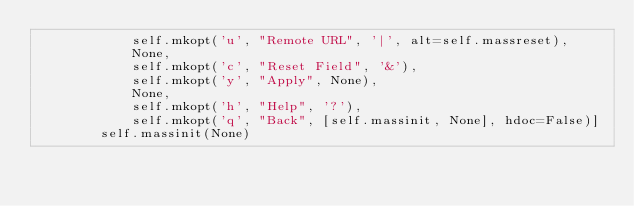<code> <loc_0><loc_0><loc_500><loc_500><_Python_>            self.mkopt('u', "Remote URL", '|', alt=self.massreset),
            None,
            self.mkopt('c', "Reset Field", '&'),
            self.mkopt('y', "Apply", None),
            None,
            self.mkopt('h', "Help", '?'),
            self.mkopt('q', "Back", [self.massinit, None], hdoc=False)]
        self.massinit(None)
</code> 